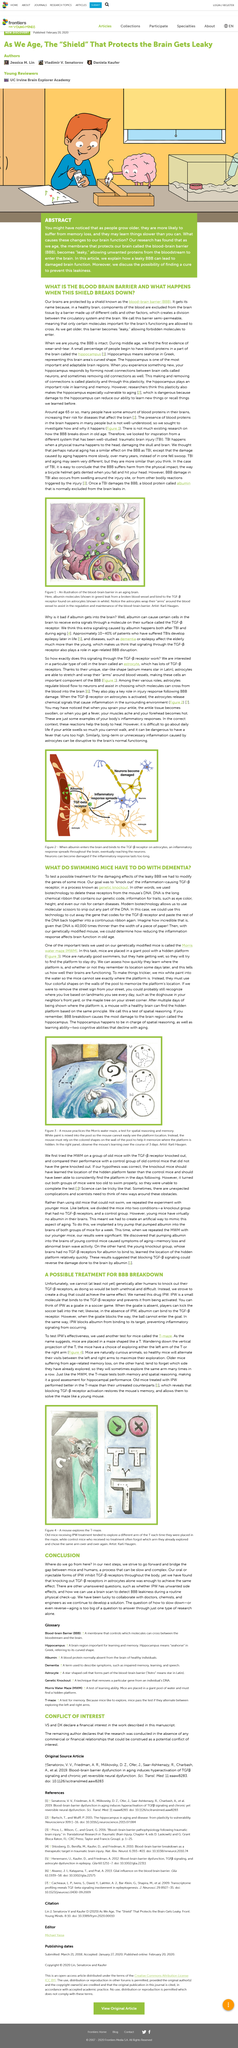Highlight a few significant elements in this photo. The protein IPW functions as a molecular switch to regulate inflammation by blocking the binding of albumin to its target, thereby preventing the activation of inflammatory signaling pathways. It is known that TBI stands for traumatic brain injury. At age 65, many individuals will have some amount of blood proteins present in their brains, which is a common occurrence in the human body. Astrocytes are star-shaped cells that play an essential role in the function of the brain. The T-maze is a reliable and valid test that assesses both memory and spatial reasoning, making it an ideal evaluation tool for hippocampal performance. 